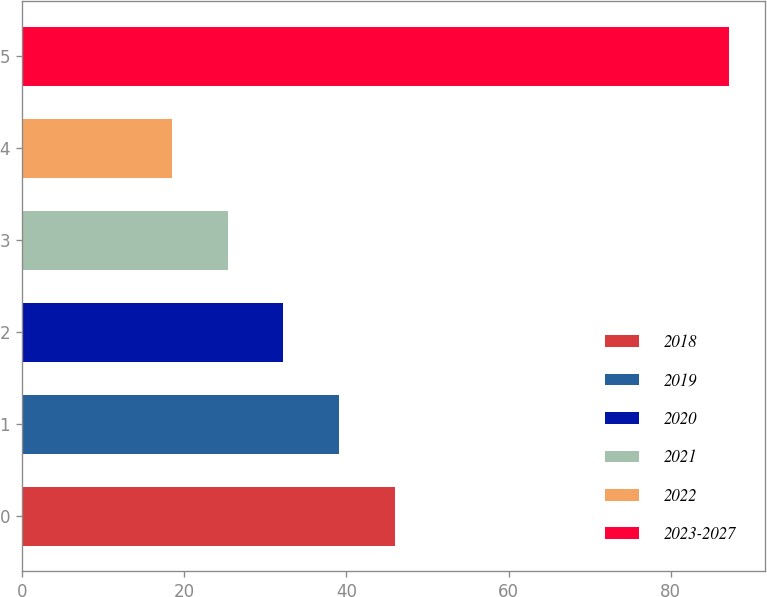Convert chart. <chart><loc_0><loc_0><loc_500><loc_500><bar_chart><fcel>2018<fcel>2019<fcel>2020<fcel>2021<fcel>2022<fcel>2023-2027<nl><fcel>45.98<fcel>39.11<fcel>32.24<fcel>25.37<fcel>18.5<fcel>87.2<nl></chart> 